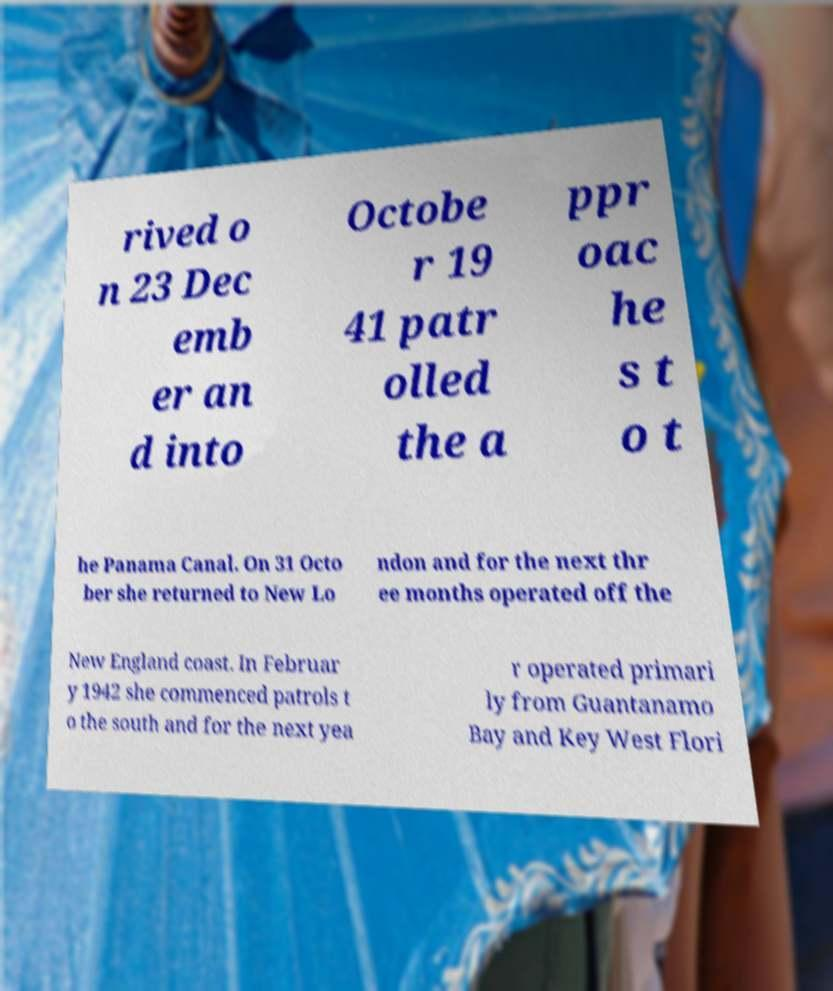There's text embedded in this image that I need extracted. Can you transcribe it verbatim? rived o n 23 Dec emb er an d into Octobe r 19 41 patr olled the a ppr oac he s t o t he Panama Canal. On 31 Octo ber she returned to New Lo ndon and for the next thr ee months operated off the New England coast. In Februar y 1942 she commenced patrols t o the south and for the next yea r operated primari ly from Guantanamo Bay and Key West Flori 